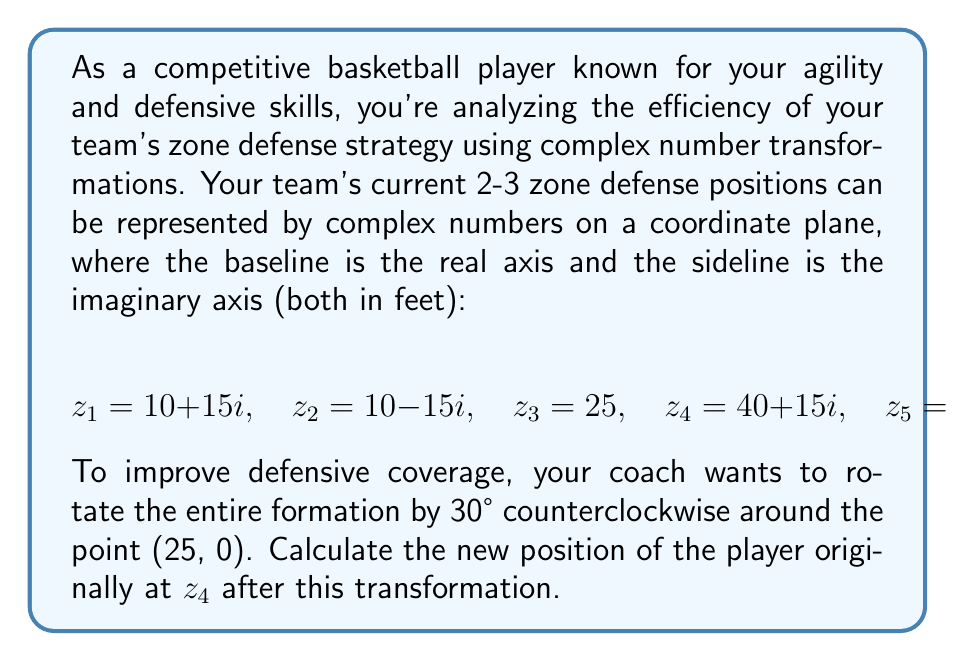Can you solve this math problem? To solve this problem, we'll follow these steps:

1) First, we need to represent the rotation and translation as a complex number transformation. The general form for such a transformation is:

   $$w = e^{i\theta}(z - z_0) + z_0$$

   where $\theta$ is the angle of rotation, $z$ is the original position, and $z_0$ is the point of rotation.

2) In this case:
   - $\theta = 30° = \frac{\pi}{6}$ radians (counterclockwise)
   - $z = z_4 = 40 + 15i$
   - $z_0 = 25$ (the point of rotation)

3) Let's substitute these into our transformation equation:

   $$w = e^{i\frac{\pi}{6}}((40 + 15i) - 25) + 25$$

4) Simplify inside the parentheses:

   $$w = e^{i\frac{\pi}{6}}(15 + 15i) + 25$$

5) Now, let's evaluate $e^{i\frac{\pi}{6}}$:

   $$e^{i\frac{\pi}{6}} = \cos(\frac{\pi}{6}) + i\sin(\frac{\pi}{6}) = \frac{\sqrt{3}}{2} + \frac{1}{2}i$$

6) Multiply this by $(15 + 15i)$:

   $$(\frac{\sqrt{3}}{2} + \frac{1}{2}i)(15 + 15i) = \frac{15\sqrt{3}}{2} + \frac{15}{2}i + \frac{15\sqrt{3}}{2}i - \frac{15}{2}$$
   
   $$= \frac{15\sqrt{3} - 15}{2} + \frac{15 + 15\sqrt{3}}{2}i$$

7) Finally, add 25:

   $$w = \frac{15\sqrt{3} - 15}{2} + 25 + \frac{15 + 15\sqrt{3}}{2}i$$

   $$= \frac{30\sqrt{3} + 35}{2} + \frac{15 + 15\sqrt{3}}{2}i$$
Answer: The new position of the player originally at $z_4$ after the transformation is:

$$\frac{30\sqrt{3} + 35}{2} + \frac{15 + 15\sqrt{3}}{2}i$$

or approximately $41.0 + 25.8i$ feet. 